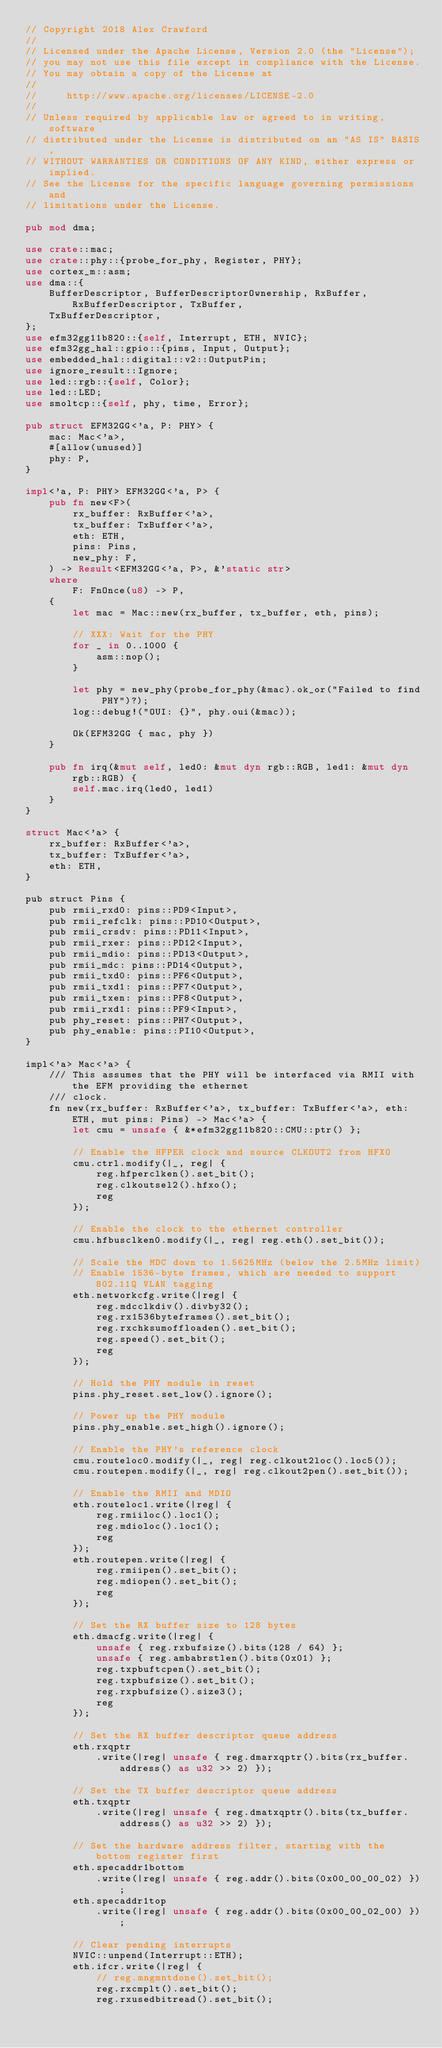<code> <loc_0><loc_0><loc_500><loc_500><_Rust_>// Copyright 2018 Alex Crawford
//
// Licensed under the Apache License, Version 2.0 (the "License");
// you may not use this file except in compliance with the License.
// You may obtain a copy of the License at
//
//     http://www.apache.org/licenses/LICENSE-2.0
//
// Unless required by applicable law or agreed to in writing, software
// distributed under the License is distributed on an "AS IS" BASIS,
// WITHOUT WARRANTIES OR CONDITIONS OF ANY KIND, either express or implied.
// See the License for the specific language governing permissions and
// limitations under the License.

pub mod dma;

use crate::mac;
use crate::phy::{probe_for_phy, Register, PHY};
use cortex_m::asm;
use dma::{
    BufferDescriptor, BufferDescriptorOwnership, RxBuffer, RxBufferDescriptor, TxBuffer,
    TxBufferDescriptor,
};
use efm32gg11b820::{self, Interrupt, ETH, NVIC};
use efm32gg_hal::gpio::{pins, Input, Output};
use embedded_hal::digital::v2::OutputPin;
use ignore_result::Ignore;
use led::rgb::{self, Color};
use led::LED;
use smoltcp::{self, phy, time, Error};

pub struct EFM32GG<'a, P: PHY> {
    mac: Mac<'a>,
    #[allow(unused)]
    phy: P,
}

impl<'a, P: PHY> EFM32GG<'a, P> {
    pub fn new<F>(
        rx_buffer: RxBuffer<'a>,
        tx_buffer: TxBuffer<'a>,
        eth: ETH,
        pins: Pins,
        new_phy: F,
    ) -> Result<EFM32GG<'a, P>, &'static str>
    where
        F: FnOnce(u8) -> P,
    {
        let mac = Mac::new(rx_buffer, tx_buffer, eth, pins);

        // XXX: Wait for the PHY
        for _ in 0..1000 {
            asm::nop();
        }

        let phy = new_phy(probe_for_phy(&mac).ok_or("Failed to find PHY")?);
        log::debug!("OUI: {}", phy.oui(&mac));

        Ok(EFM32GG { mac, phy })
    }

    pub fn irq(&mut self, led0: &mut dyn rgb::RGB, led1: &mut dyn rgb::RGB) {
        self.mac.irq(led0, led1)
    }
}

struct Mac<'a> {
    rx_buffer: RxBuffer<'a>,
    tx_buffer: TxBuffer<'a>,
    eth: ETH,
}

pub struct Pins {
    pub rmii_rxd0: pins::PD9<Input>,
    pub rmii_refclk: pins::PD10<Output>,
    pub rmii_crsdv: pins::PD11<Input>,
    pub rmii_rxer: pins::PD12<Input>,
    pub rmii_mdio: pins::PD13<Output>,
    pub rmii_mdc: pins::PD14<Output>,
    pub rmii_txd0: pins::PF6<Output>,
    pub rmii_txd1: pins::PF7<Output>,
    pub rmii_txen: pins::PF8<Output>,
    pub rmii_rxd1: pins::PF9<Input>,
    pub phy_reset: pins::PH7<Output>,
    pub phy_enable: pins::PI10<Output>,
}

impl<'a> Mac<'a> {
    /// This assumes that the PHY will be interfaced via RMII with the EFM providing the ethernet
    /// clock.
    fn new(rx_buffer: RxBuffer<'a>, tx_buffer: TxBuffer<'a>, eth: ETH, mut pins: Pins) -> Mac<'a> {
        let cmu = unsafe { &*efm32gg11b820::CMU::ptr() };

        // Enable the HFPER clock and source CLKOUT2 from HFXO
        cmu.ctrl.modify(|_, reg| {
            reg.hfperclken().set_bit();
            reg.clkoutsel2().hfxo();
            reg
        });

        // Enable the clock to the ethernet controller
        cmu.hfbusclken0.modify(|_, reg| reg.eth().set_bit());

        // Scale the MDC down to 1.5625MHz (below the 2.5MHz limit)
        // Enable 1536-byte frames, which are needed to support 802.11Q VLAN tagging
        eth.networkcfg.write(|reg| {
            reg.mdcclkdiv().divby32();
            reg.rx1536byteframes().set_bit();
            reg.rxchksumoffloaden().set_bit();
            reg.speed().set_bit();
            reg
        });

        // Hold the PHY module in reset
        pins.phy_reset.set_low().ignore();

        // Power up the PHY module
        pins.phy_enable.set_high().ignore();

        // Enable the PHY's reference clock
        cmu.routeloc0.modify(|_, reg| reg.clkout2loc().loc5());
        cmu.routepen.modify(|_, reg| reg.clkout2pen().set_bit());

        // Enable the RMII and MDIO
        eth.routeloc1.write(|reg| {
            reg.rmiiloc().loc1();
            reg.mdioloc().loc1();
            reg
        });
        eth.routepen.write(|reg| {
            reg.rmiipen().set_bit();
            reg.mdiopen().set_bit();
            reg
        });

        // Set the RX buffer size to 128 bytes
        eth.dmacfg.write(|reg| {
            unsafe { reg.rxbufsize().bits(128 / 64) };
            unsafe { reg.ambabrstlen().bits(0x01) };
            reg.txpbuftcpen().set_bit();
            reg.txpbufsize().set_bit();
            reg.rxpbufsize().size3();
            reg
        });

        // Set the RX buffer descriptor queue address
        eth.rxqptr
            .write(|reg| unsafe { reg.dmarxqptr().bits(rx_buffer.address() as u32 >> 2) });

        // Set the TX buffer descriptor queue address
        eth.txqptr
            .write(|reg| unsafe { reg.dmatxqptr().bits(tx_buffer.address() as u32 >> 2) });

        // Set the hardware address filter, starting with the bottom register first
        eth.specaddr1bottom
            .write(|reg| unsafe { reg.addr().bits(0x00_00_00_02) });
        eth.specaddr1top
            .write(|reg| unsafe { reg.addr().bits(0x00_00_02_00) });

        // Clear pending interrupts
        NVIC::unpend(Interrupt::ETH);
        eth.ifcr.write(|reg| {
            // reg.mngmntdone().set_bit();
            reg.rxcmplt().set_bit();
            reg.rxusedbitread().set_bit();</code> 